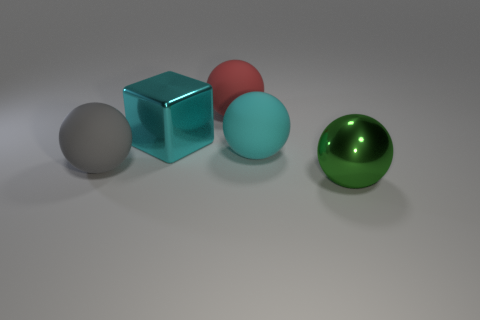Subtract 2 spheres. How many spheres are left? 2 Add 1 large red rubber spheres. How many objects exist? 6 Subtract all rubber balls. How many balls are left? 1 Subtract all cyan balls. How many balls are left? 3 Subtract all cubes. How many objects are left? 4 Subtract all blue spheres. Subtract all gray cylinders. How many spheres are left? 4 Subtract all large red objects. Subtract all green objects. How many objects are left? 3 Add 3 big gray matte things. How many big gray matte things are left? 4 Add 1 cyan things. How many cyan things exist? 3 Subtract 0 brown cylinders. How many objects are left? 5 